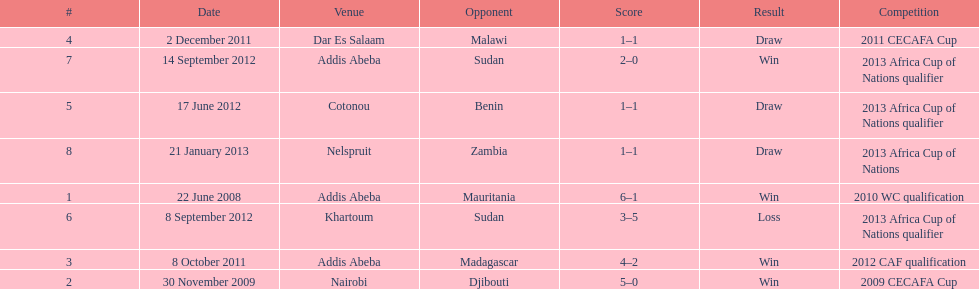Number of different teams listed on the chart 7. 